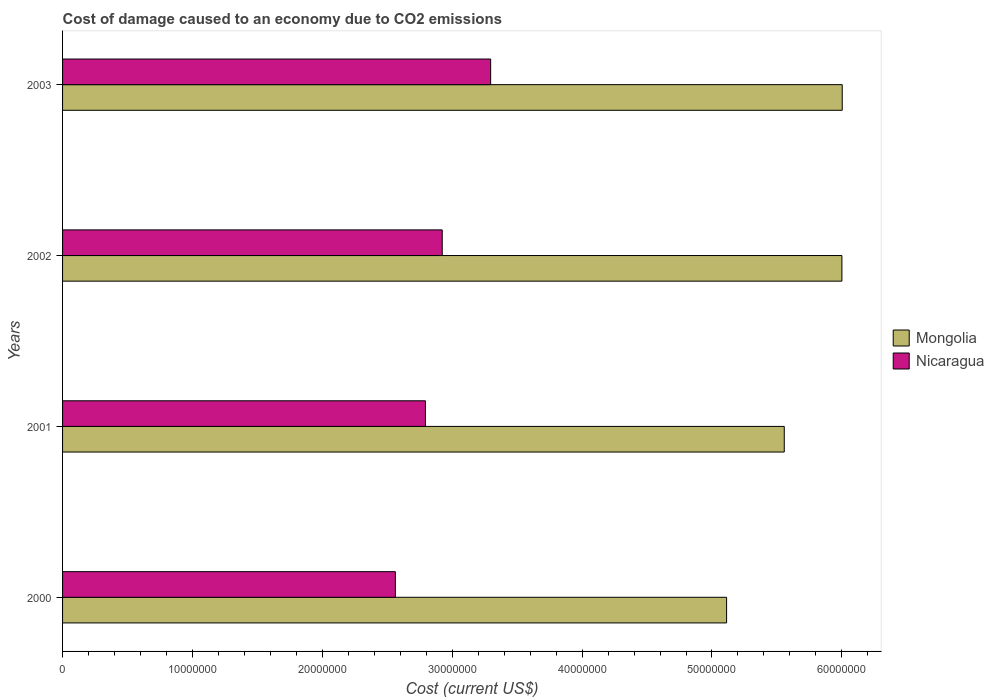How many different coloured bars are there?
Ensure brevity in your answer.  2. Are the number of bars per tick equal to the number of legend labels?
Provide a short and direct response. Yes. How many bars are there on the 2nd tick from the top?
Offer a very short reply. 2. What is the label of the 2nd group of bars from the top?
Make the answer very short. 2002. What is the cost of damage caused due to CO2 emissisons in Mongolia in 2001?
Make the answer very short. 5.56e+07. Across all years, what is the maximum cost of damage caused due to CO2 emissisons in Nicaragua?
Your response must be concise. 3.30e+07. Across all years, what is the minimum cost of damage caused due to CO2 emissisons in Mongolia?
Your response must be concise. 5.11e+07. In which year was the cost of damage caused due to CO2 emissisons in Nicaragua maximum?
Offer a very short reply. 2003. What is the total cost of damage caused due to CO2 emissisons in Nicaragua in the graph?
Ensure brevity in your answer.  1.16e+08. What is the difference between the cost of damage caused due to CO2 emissisons in Mongolia in 2000 and that in 2002?
Offer a very short reply. -8.88e+06. What is the difference between the cost of damage caused due to CO2 emissisons in Mongolia in 2001 and the cost of damage caused due to CO2 emissisons in Nicaragua in 2003?
Your response must be concise. 2.26e+07. What is the average cost of damage caused due to CO2 emissisons in Mongolia per year?
Your response must be concise. 5.67e+07. In the year 2000, what is the difference between the cost of damage caused due to CO2 emissisons in Mongolia and cost of damage caused due to CO2 emissisons in Nicaragua?
Provide a succinct answer. 2.55e+07. In how many years, is the cost of damage caused due to CO2 emissisons in Mongolia greater than 14000000 US$?
Offer a very short reply. 4. What is the ratio of the cost of damage caused due to CO2 emissisons in Mongolia in 2001 to that in 2002?
Offer a terse response. 0.93. Is the difference between the cost of damage caused due to CO2 emissisons in Mongolia in 2001 and 2002 greater than the difference between the cost of damage caused due to CO2 emissisons in Nicaragua in 2001 and 2002?
Offer a terse response. No. What is the difference between the highest and the second highest cost of damage caused due to CO2 emissisons in Mongolia?
Ensure brevity in your answer.  2.54e+04. What is the difference between the highest and the lowest cost of damage caused due to CO2 emissisons in Nicaragua?
Ensure brevity in your answer.  7.33e+06. Is the sum of the cost of damage caused due to CO2 emissisons in Nicaragua in 2000 and 2002 greater than the maximum cost of damage caused due to CO2 emissisons in Mongolia across all years?
Provide a succinct answer. No. What does the 2nd bar from the top in 2001 represents?
Offer a very short reply. Mongolia. What does the 2nd bar from the bottom in 2000 represents?
Your answer should be very brief. Nicaragua. Are all the bars in the graph horizontal?
Offer a terse response. Yes. How many years are there in the graph?
Your response must be concise. 4. Are the values on the major ticks of X-axis written in scientific E-notation?
Make the answer very short. No. Does the graph contain any zero values?
Provide a succinct answer. No. How are the legend labels stacked?
Your answer should be very brief. Vertical. What is the title of the graph?
Your answer should be very brief. Cost of damage caused to an economy due to CO2 emissions. Does "Tuvalu" appear as one of the legend labels in the graph?
Your answer should be compact. No. What is the label or title of the X-axis?
Make the answer very short. Cost (current US$). What is the Cost (current US$) of Mongolia in 2000?
Provide a succinct answer. 5.11e+07. What is the Cost (current US$) of Nicaragua in 2000?
Ensure brevity in your answer.  2.56e+07. What is the Cost (current US$) of Mongolia in 2001?
Your answer should be very brief. 5.56e+07. What is the Cost (current US$) in Nicaragua in 2001?
Make the answer very short. 2.79e+07. What is the Cost (current US$) of Mongolia in 2002?
Provide a short and direct response. 6.00e+07. What is the Cost (current US$) in Nicaragua in 2002?
Provide a succinct answer. 2.92e+07. What is the Cost (current US$) of Mongolia in 2003?
Make the answer very short. 6.00e+07. What is the Cost (current US$) of Nicaragua in 2003?
Offer a terse response. 3.30e+07. Across all years, what is the maximum Cost (current US$) of Mongolia?
Your answer should be very brief. 6.00e+07. Across all years, what is the maximum Cost (current US$) in Nicaragua?
Offer a very short reply. 3.30e+07. Across all years, what is the minimum Cost (current US$) in Mongolia?
Give a very brief answer. 5.11e+07. Across all years, what is the minimum Cost (current US$) in Nicaragua?
Offer a very short reply. 2.56e+07. What is the total Cost (current US$) in Mongolia in the graph?
Offer a very short reply. 2.27e+08. What is the total Cost (current US$) in Nicaragua in the graph?
Offer a terse response. 1.16e+08. What is the difference between the Cost (current US$) in Mongolia in 2000 and that in 2001?
Give a very brief answer. -4.44e+06. What is the difference between the Cost (current US$) in Nicaragua in 2000 and that in 2001?
Give a very brief answer. -2.31e+06. What is the difference between the Cost (current US$) of Mongolia in 2000 and that in 2002?
Ensure brevity in your answer.  -8.88e+06. What is the difference between the Cost (current US$) in Nicaragua in 2000 and that in 2002?
Provide a short and direct response. -3.61e+06. What is the difference between the Cost (current US$) in Mongolia in 2000 and that in 2003?
Provide a short and direct response. -8.90e+06. What is the difference between the Cost (current US$) of Nicaragua in 2000 and that in 2003?
Offer a very short reply. -7.33e+06. What is the difference between the Cost (current US$) of Mongolia in 2001 and that in 2002?
Your answer should be compact. -4.44e+06. What is the difference between the Cost (current US$) of Nicaragua in 2001 and that in 2002?
Offer a very short reply. -1.29e+06. What is the difference between the Cost (current US$) in Mongolia in 2001 and that in 2003?
Keep it short and to the point. -4.46e+06. What is the difference between the Cost (current US$) of Nicaragua in 2001 and that in 2003?
Make the answer very short. -5.02e+06. What is the difference between the Cost (current US$) of Mongolia in 2002 and that in 2003?
Your answer should be compact. -2.54e+04. What is the difference between the Cost (current US$) of Nicaragua in 2002 and that in 2003?
Keep it short and to the point. -3.73e+06. What is the difference between the Cost (current US$) of Mongolia in 2000 and the Cost (current US$) of Nicaragua in 2001?
Give a very brief answer. 2.32e+07. What is the difference between the Cost (current US$) of Mongolia in 2000 and the Cost (current US$) of Nicaragua in 2002?
Keep it short and to the point. 2.19e+07. What is the difference between the Cost (current US$) of Mongolia in 2000 and the Cost (current US$) of Nicaragua in 2003?
Your response must be concise. 1.82e+07. What is the difference between the Cost (current US$) of Mongolia in 2001 and the Cost (current US$) of Nicaragua in 2002?
Offer a very short reply. 2.63e+07. What is the difference between the Cost (current US$) in Mongolia in 2001 and the Cost (current US$) in Nicaragua in 2003?
Your response must be concise. 2.26e+07. What is the difference between the Cost (current US$) of Mongolia in 2002 and the Cost (current US$) of Nicaragua in 2003?
Provide a short and direct response. 2.70e+07. What is the average Cost (current US$) of Mongolia per year?
Your response must be concise. 5.67e+07. What is the average Cost (current US$) in Nicaragua per year?
Provide a short and direct response. 2.89e+07. In the year 2000, what is the difference between the Cost (current US$) in Mongolia and Cost (current US$) in Nicaragua?
Give a very brief answer. 2.55e+07. In the year 2001, what is the difference between the Cost (current US$) in Mongolia and Cost (current US$) in Nicaragua?
Provide a short and direct response. 2.76e+07. In the year 2002, what is the difference between the Cost (current US$) of Mongolia and Cost (current US$) of Nicaragua?
Offer a terse response. 3.08e+07. In the year 2003, what is the difference between the Cost (current US$) in Mongolia and Cost (current US$) in Nicaragua?
Keep it short and to the point. 2.71e+07. What is the ratio of the Cost (current US$) in Mongolia in 2000 to that in 2001?
Provide a short and direct response. 0.92. What is the ratio of the Cost (current US$) in Nicaragua in 2000 to that in 2001?
Your response must be concise. 0.92. What is the ratio of the Cost (current US$) of Mongolia in 2000 to that in 2002?
Offer a terse response. 0.85. What is the ratio of the Cost (current US$) of Nicaragua in 2000 to that in 2002?
Make the answer very short. 0.88. What is the ratio of the Cost (current US$) of Mongolia in 2000 to that in 2003?
Provide a succinct answer. 0.85. What is the ratio of the Cost (current US$) in Nicaragua in 2000 to that in 2003?
Give a very brief answer. 0.78. What is the ratio of the Cost (current US$) of Mongolia in 2001 to that in 2002?
Provide a short and direct response. 0.93. What is the ratio of the Cost (current US$) in Nicaragua in 2001 to that in 2002?
Ensure brevity in your answer.  0.96. What is the ratio of the Cost (current US$) of Mongolia in 2001 to that in 2003?
Make the answer very short. 0.93. What is the ratio of the Cost (current US$) of Nicaragua in 2001 to that in 2003?
Your response must be concise. 0.85. What is the ratio of the Cost (current US$) of Mongolia in 2002 to that in 2003?
Give a very brief answer. 1. What is the ratio of the Cost (current US$) in Nicaragua in 2002 to that in 2003?
Make the answer very short. 0.89. What is the difference between the highest and the second highest Cost (current US$) in Mongolia?
Offer a terse response. 2.54e+04. What is the difference between the highest and the second highest Cost (current US$) of Nicaragua?
Make the answer very short. 3.73e+06. What is the difference between the highest and the lowest Cost (current US$) of Mongolia?
Make the answer very short. 8.90e+06. What is the difference between the highest and the lowest Cost (current US$) in Nicaragua?
Your answer should be compact. 7.33e+06. 